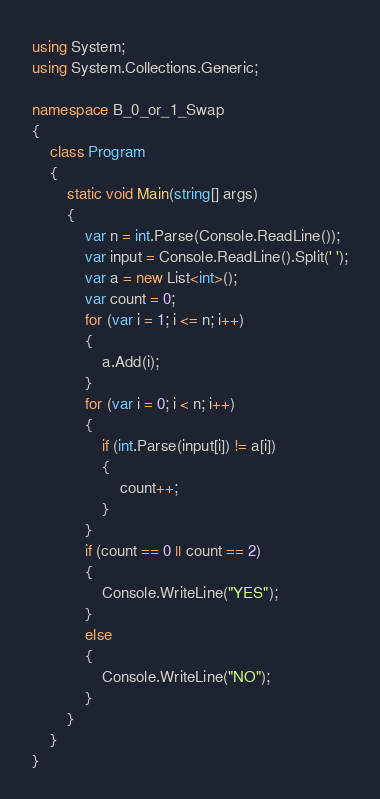<code> <loc_0><loc_0><loc_500><loc_500><_C#_>using System;
using System.Collections.Generic;

namespace B_0_or_1_Swap
{
    class Program
    {
        static void Main(string[] args)
        {
            var n = int.Parse(Console.ReadLine());
            var input = Console.ReadLine().Split(' ');
            var a = new List<int>();
            var count = 0;
            for (var i = 1; i <= n; i++)
            {
                a.Add(i);
            }
            for (var i = 0; i < n; i++)
            {
                if (int.Parse(input[i]) != a[i])
                {
                    count++;
                }
            }
            if (count == 0 || count == 2)
            {
                Console.WriteLine("YES");
            }
            else
            {
                Console.WriteLine("NO");
            }
        }
    }
}</code> 